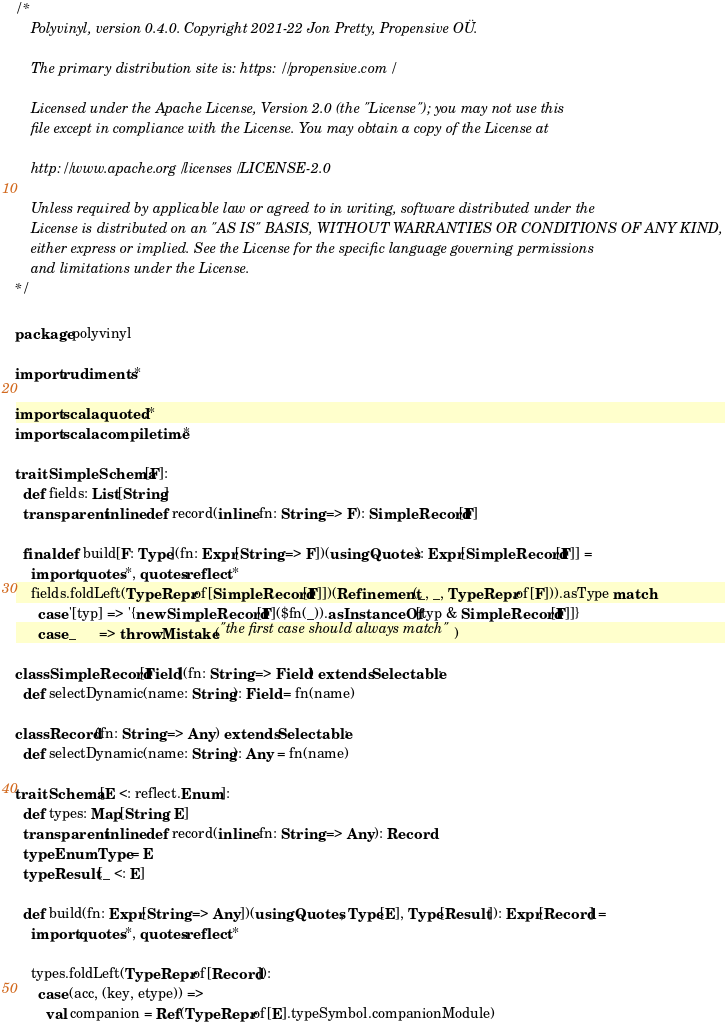<code> <loc_0><loc_0><loc_500><loc_500><_Scala_>/*
    Polyvinyl, version 0.4.0. Copyright 2021-22 Jon Pretty, Propensive OÜ.

    The primary distribution site is: https://propensive.com/

    Licensed under the Apache License, Version 2.0 (the "License"); you may not use this
    file except in compliance with the License. You may obtain a copy of the License at

    http://www.apache.org/licenses/LICENSE-2.0

    Unless required by applicable law or agreed to in writing, software distributed under the
    License is distributed on an "AS IS" BASIS, WITHOUT WARRANTIES OR CONDITIONS OF ANY KIND,
    either express or implied. See the License for the specific language governing permissions
    and limitations under the License.
*/

package polyvinyl

import rudiments.*

import scala.quoted.*
import scala.compiletime.*

trait SimpleSchema[F]:
  def fields: List[String]
  transparent inline def record(inline fn: String => F): SimpleRecord[F]
  
  final def build[F: Type](fn: Expr[String => F])(using Quotes): Expr[SimpleRecord[F]] =
    import quotes.*, quotes.reflect.*
    fields.foldLeft(TypeRepr.of[SimpleRecord[F]])(Refinement(_, _, TypeRepr.of[F])).asType match
      case '[typ] => '{new SimpleRecord[F]($fn(_)).asInstanceOf[typ & SimpleRecord[F]]}
      case _      => throw Mistake("the first case should always match")
  
class SimpleRecord[Field](fn: String => Field) extends Selectable:
  def selectDynamic(name: String): Field = fn(name)

class Record(fn: String => Any) extends Selectable:
  def selectDynamic(name: String): Any = fn(name)

trait Schema[E <: reflect.Enum]:
  def types: Map[String, E]
  transparent inline def record(inline fn: String => Any): Record
  type EnumType = E
  type Result[_ <: E]

  def build(fn: Expr[String => Any])(using Quotes, Type[E], Type[Result]): Expr[Record] =
    import quotes.*, quotes.reflect.*

    types.foldLeft(TypeRepr.of[Record]):
      case (acc, (key, etype)) =>
        val companion = Ref(TypeRepr.of[E].typeSymbol.companionModule)</code> 